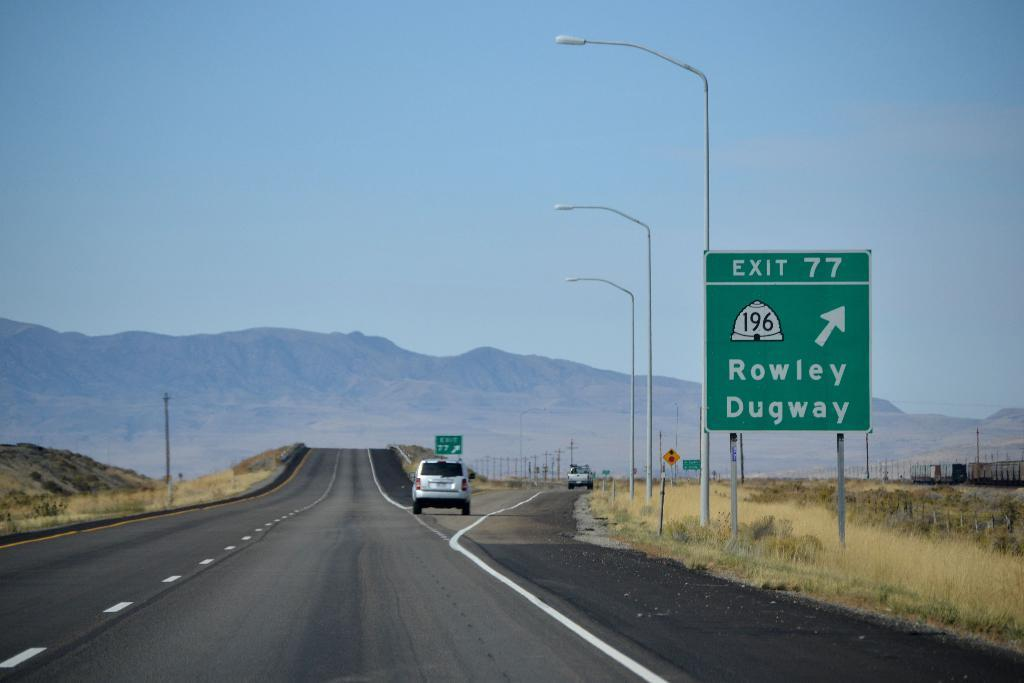<image>
Give a short and clear explanation of the subsequent image. Green and white highway sign which says ROWLEY DUGWAY. 